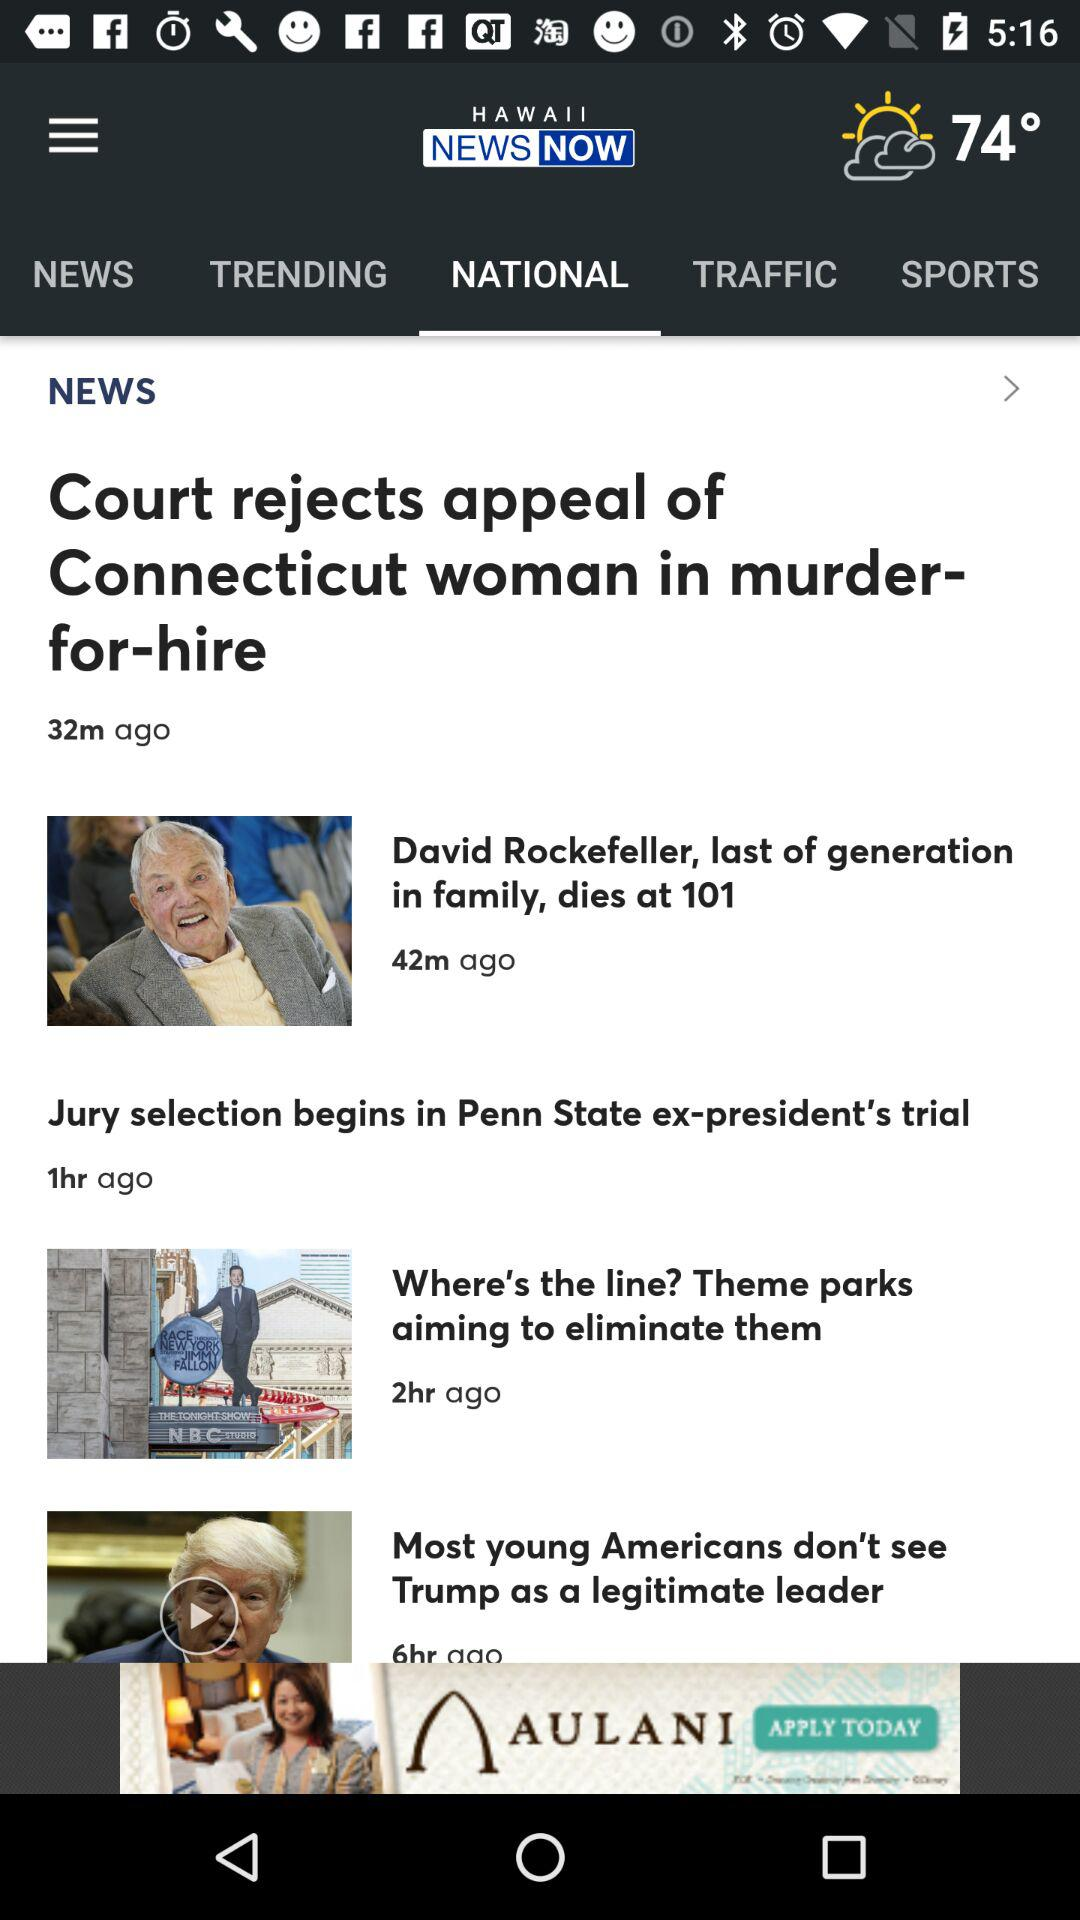What is the application name? The application name is "HAWAII NEWS NOW". 